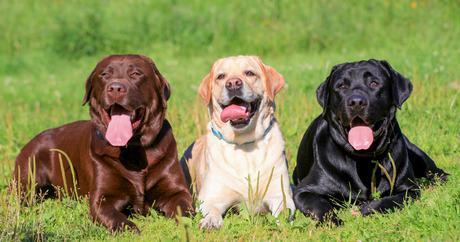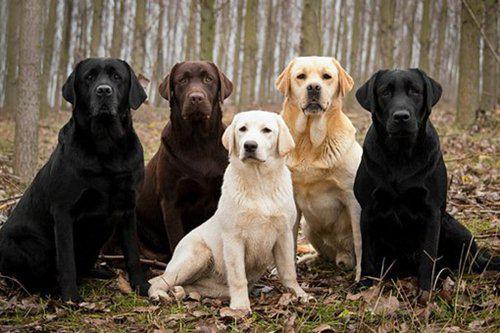The first image is the image on the left, the second image is the image on the right. For the images shown, is this caption "There are exactly 2 dogs in the left image." true? Answer yes or no. No. 